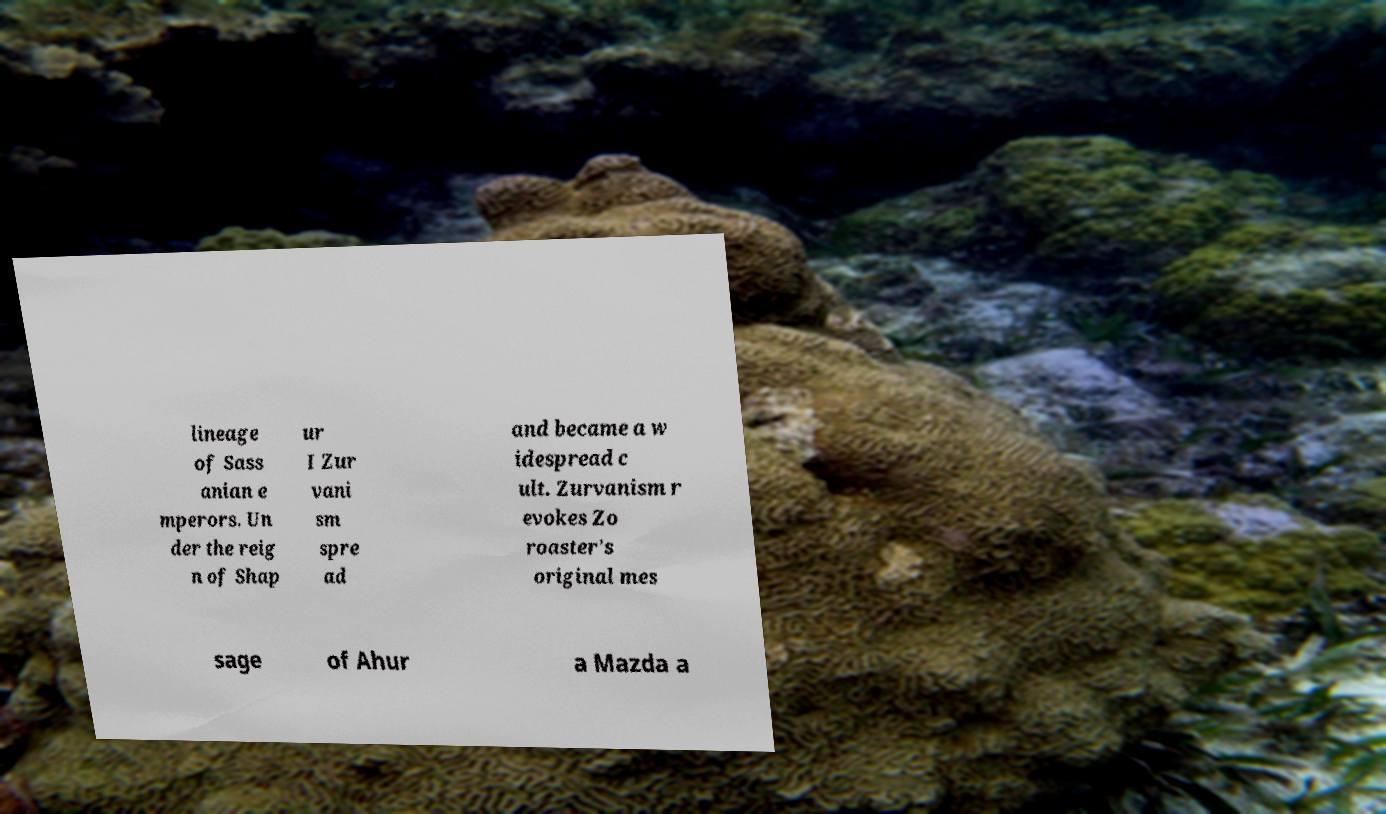Please identify and transcribe the text found in this image. lineage of Sass anian e mperors. Un der the reig n of Shap ur I Zur vani sm spre ad and became a w idespread c ult. Zurvanism r evokes Zo roaster's original mes sage of Ahur a Mazda a 